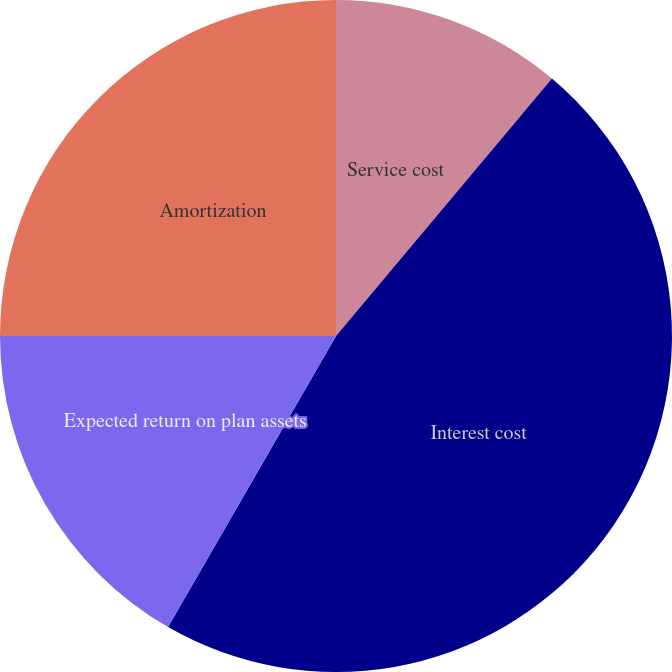<chart> <loc_0><loc_0><loc_500><loc_500><pie_chart><fcel>Service cost<fcel>Interest cost<fcel>Expected return on plan assets<fcel>Amortization<nl><fcel>11.11%<fcel>47.22%<fcel>16.67%<fcel>25.0%<nl></chart> 